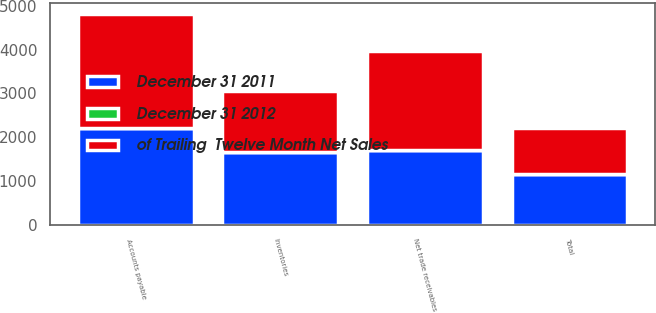Convert chart to OTSL. <chart><loc_0><loc_0><loc_500><loc_500><stacked_bar_chart><ecel><fcel>Net trade receivables<fcel>Inventories<fcel>Accounts payable<fcel>Total<nl><fcel>December 31 2011<fcel>1708<fcel>1657<fcel>2202<fcel>1163<nl><fcel>December 31 2012<fcel>9.7<fcel>9.4<fcel>12.5<fcel>6.6<nl><fcel>of Trailing  Twelve Month Net Sales<fcel>2250<fcel>1384<fcel>2603<fcel>1031<nl></chart> 